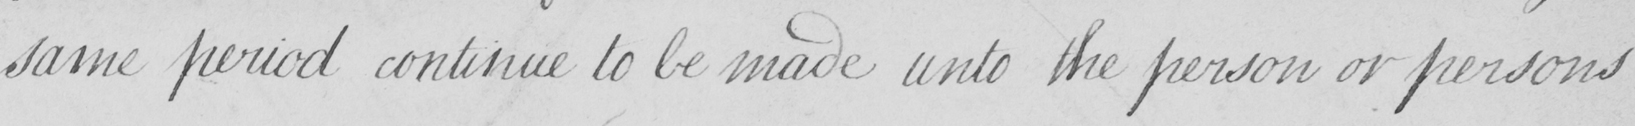Please transcribe the handwritten text in this image. same period continue to be made unto the person or persons 